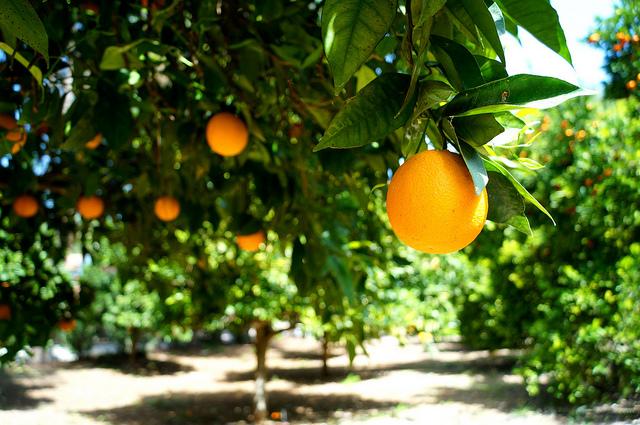Are the oranges ripe?
Write a very short answer. Yes. What fruit is this?
Answer briefly. Orange. Is this a vineyard?
Quick response, please. No. 